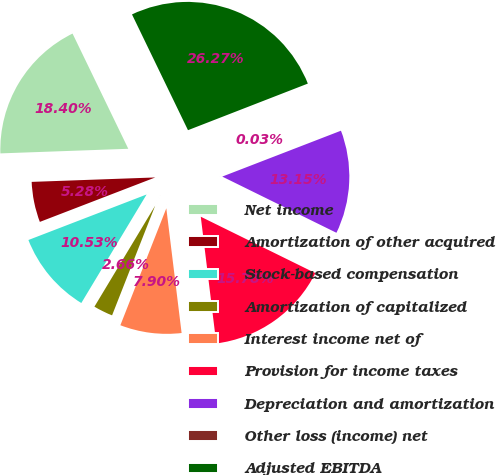<chart> <loc_0><loc_0><loc_500><loc_500><pie_chart><fcel>Net income<fcel>Amortization of other acquired<fcel>Stock-based compensation<fcel>Amortization of capitalized<fcel>Interest income net of<fcel>Provision for income taxes<fcel>Depreciation and amortization<fcel>Other loss (income) net<fcel>Adjusted EBITDA<nl><fcel>18.4%<fcel>5.28%<fcel>10.53%<fcel>2.66%<fcel>7.9%<fcel>15.78%<fcel>13.15%<fcel>0.03%<fcel>26.27%<nl></chart> 